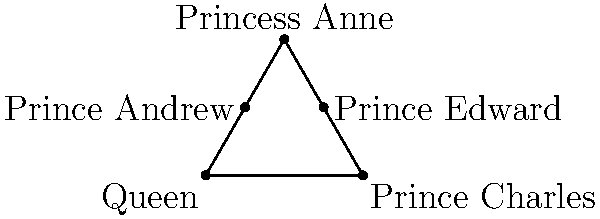In the royal family's Christmas dinner seating arrangement shown above, which two family members form a line of symmetry for the triangle when connected? To determine the line of symmetry in this triangular seating arrangement, we need to follow these steps:

1. Observe that the seating arrangement forms an equilateral triangle with the Queen, Prince Charles, and Princess Anne at the vertices.

2. Prince Andrew and Prince Edward are seated on the sides of the triangle.

3. A line of symmetry in an equilateral triangle bisects a vertex angle and is perpendicular to the opposite side, dividing it into two equal parts.

4. Looking at the diagram, we can see that the line connecting the Queen (at the bottom vertex) and Princess Anne (at the top vertex) would fulfill this condition.

5. This line would pass through the center of the triangle, creating two equal halves with Prince Andrew on one side and Prince Edward on the other.

6. Therefore, the line connecting the Queen and Princess Anne forms a line of symmetry for the triangular seating arrangement.
Answer: Queen and Princess Anne 